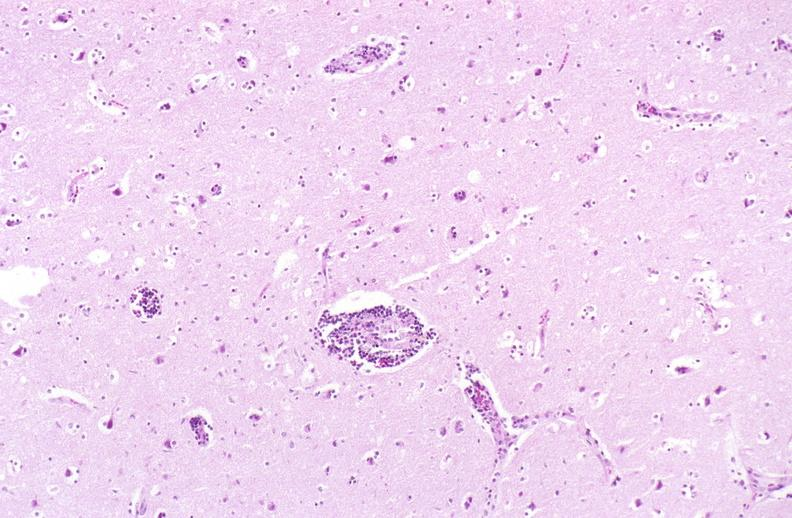s nervous present?
Answer the question using a single word or phrase. Yes 